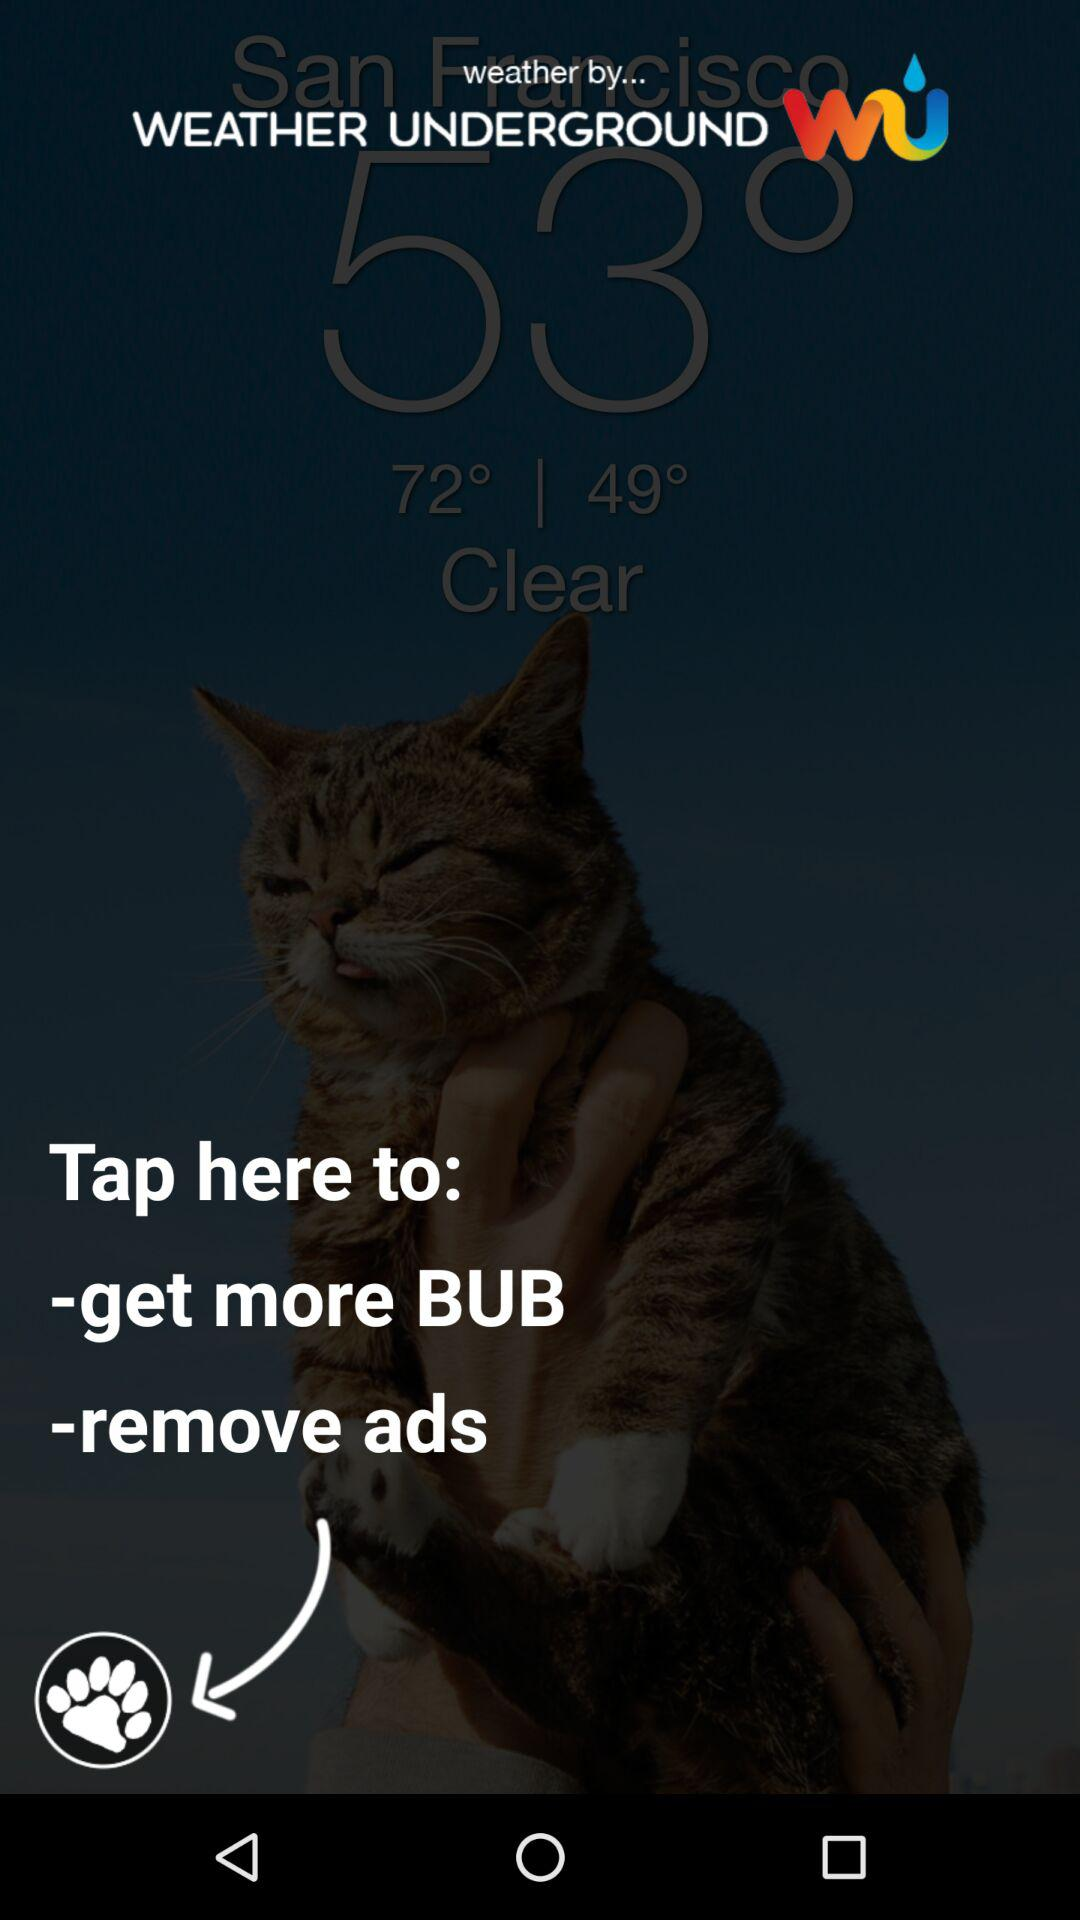What is the name of the application? The name of the application is "WEATHER UNDERGROUND". 